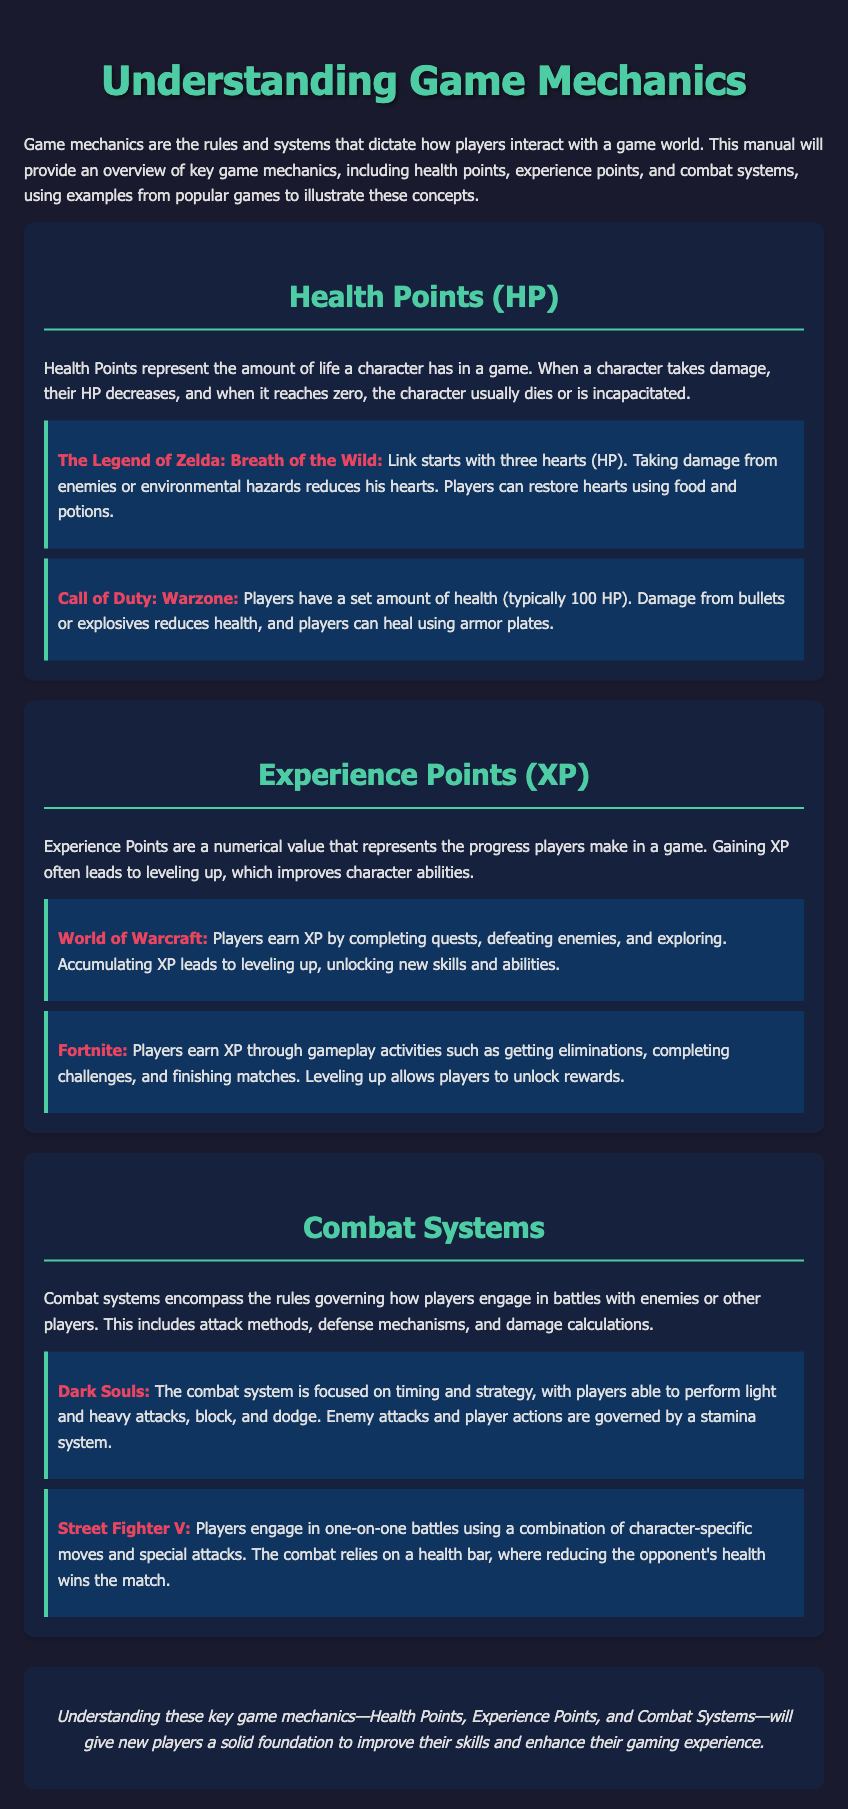What do Health Points represent? Health Points represent the amount of life a character has in a game.
Answer: amount of life How many hearts does Link start with in The Legend of Zelda: Breath of the Wild? Link starts with three hearts (HP).
Answer: three hearts What is the maximum amount of health players typically have in Call of Duty: Warzone? Players have a set amount of health (typically 100 HP).
Answer: 100 HP What do Experience Points lead to in games? Gaining XP often leads to leveling up, which improves character abilities.
Answer: leveling up Which game allows players to earn XP by completing quests, defeating enemies, and exploring? Players earn XP by completing quests, defeating enemies, and exploring in World of Warcraft.
Answer: World of Warcraft What does the combat system in Dark Souls focus on? The combat system is focused on timing and strategy.
Answer: timing and strategy What type of battles does Street Fighter V feature? Players engage in one-on-one battles using a combination of character-specific moves and special attacks.
Answer: one-on-one battles What is the primary focus of Health Points in the document? Health Points are designed to indicate player survival and damage taken.
Answer: player survival What does the conclusion provide regarding the key game mechanics? Understanding these key game mechanics will give new players a solid foundation to improve their skills.
Answer: solid foundation 